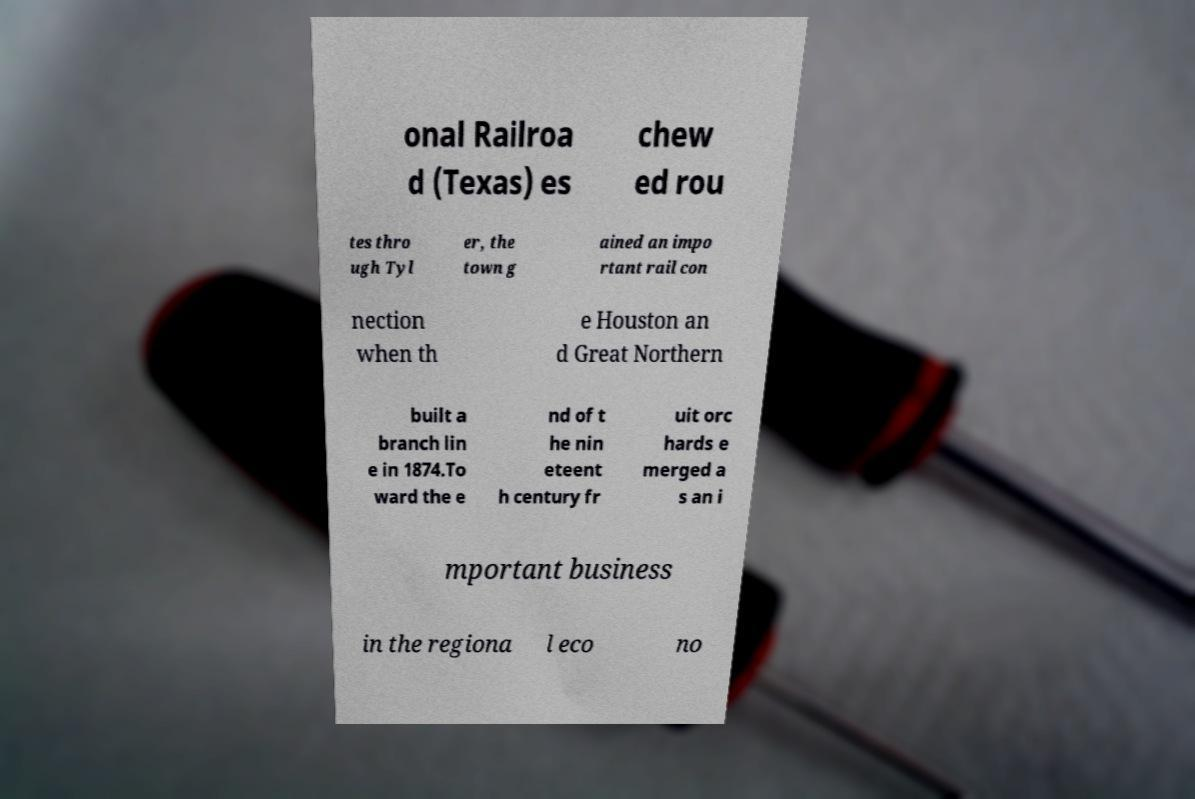Can you read and provide the text displayed in the image?This photo seems to have some interesting text. Can you extract and type it out for me? onal Railroa d (Texas) es chew ed rou tes thro ugh Tyl er, the town g ained an impo rtant rail con nection when th e Houston an d Great Northern built a branch lin e in 1874.To ward the e nd of t he nin eteent h century fr uit orc hards e merged a s an i mportant business in the regiona l eco no 